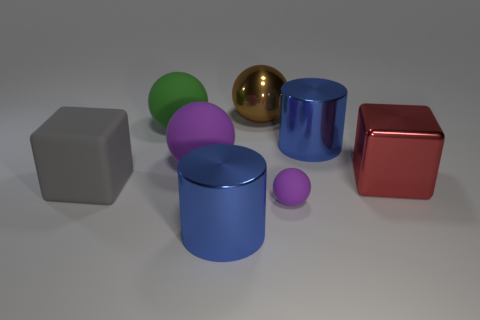What material is the gray thing?
Ensure brevity in your answer.  Rubber. There is a red object that is the same size as the gray block; what is its shape?
Your answer should be compact. Cube. Are there any cylinders that have the same color as the rubber block?
Keep it short and to the point. No. There is a tiny matte object; is its color the same as the cylinder that is right of the large brown ball?
Provide a short and direct response. No. The block that is right of the large green object that is behind the tiny matte ball is what color?
Your answer should be compact. Red. There is a object that is to the right of the blue metallic thing that is behind the red cube; are there any metallic things that are behind it?
Provide a succinct answer. Yes. What color is the small ball that is made of the same material as the large gray thing?
Keep it short and to the point. Purple. How many green objects are the same material as the small purple ball?
Provide a succinct answer. 1. Does the gray thing have the same material as the large cylinder behind the large red thing?
Your answer should be compact. No. How many things are either big blue things in front of the large red cube or big matte objects?
Provide a short and direct response. 4. 